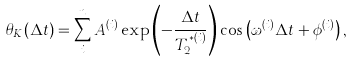Convert formula to latex. <formula><loc_0><loc_0><loc_500><loc_500>\theta _ { K } ( \Delta t ) = \sum _ { i } ^ { n } A ^ { ( i ) } \exp \left ( - \frac { \Delta t } { T _ { 2 } ^ { * ( i ) } } \right ) \cos \left ( \omega ^ { ( i ) } \Delta t + \phi ^ { ( i ) } \right ) ,</formula> 